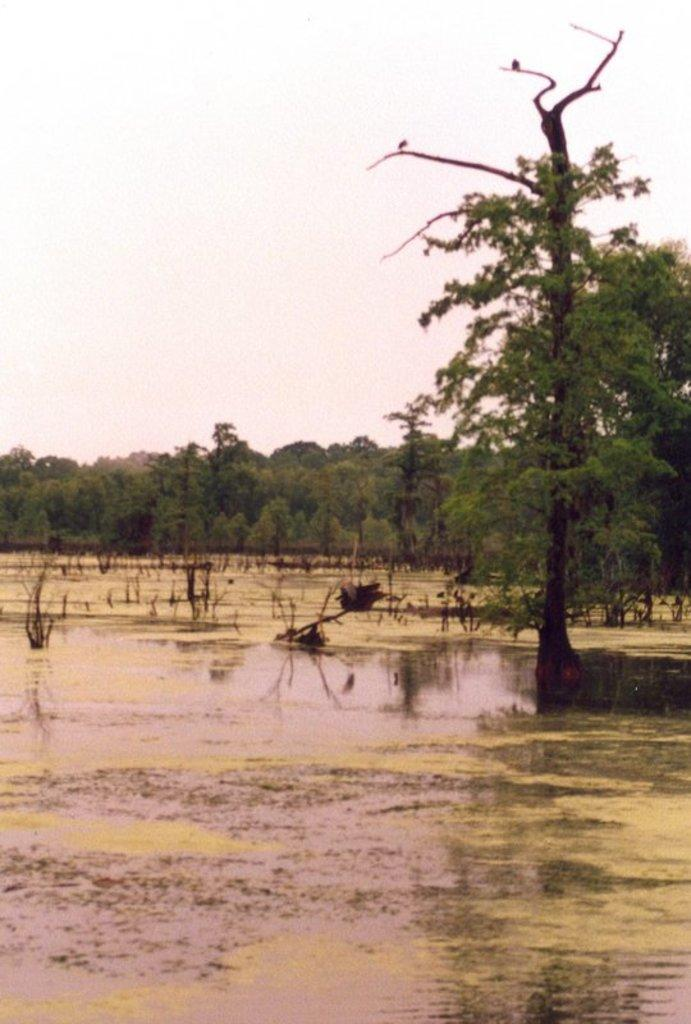What is the primary element visible in the image? There is water in the image. What types of vegetation can be seen in the image? There are plants and trees in the image. What can be seen in the background of the image? The sky is visible in the background of the image. What is the taste of the water in the image? The taste of the water cannot be determined from the image alone, as taste is a sensory experience that cannot be conveyed visually. 